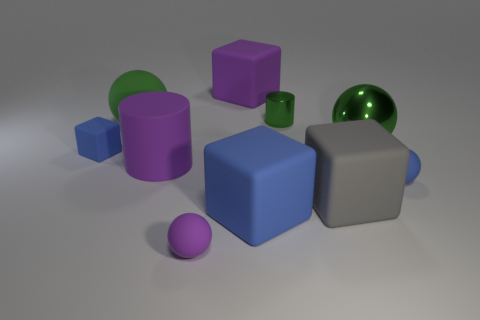Subtract 1 blocks. How many blocks are left? 3 Subtract all cylinders. How many objects are left? 8 Add 8 rubber cylinders. How many rubber cylinders exist? 9 Subtract 0 red cubes. How many objects are left? 10 Subtract all big shiny spheres. Subtract all big blue rubber blocks. How many objects are left? 8 Add 5 gray rubber blocks. How many gray rubber blocks are left? 6 